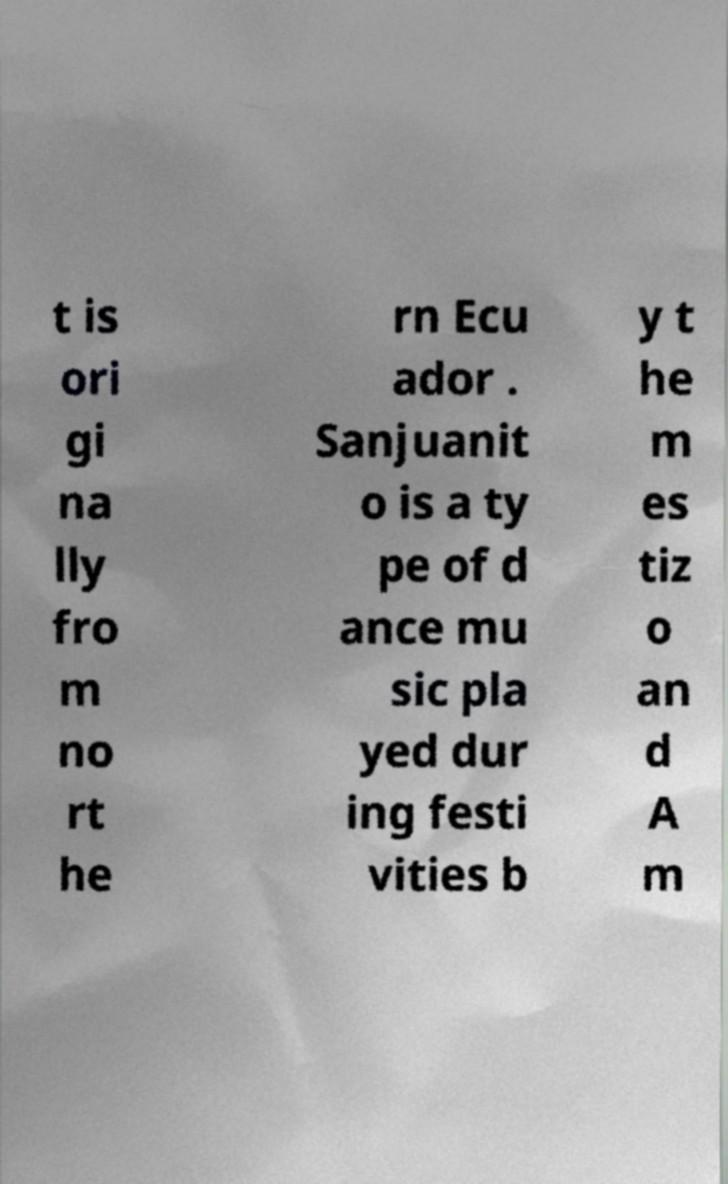Can you read and provide the text displayed in the image?This photo seems to have some interesting text. Can you extract and type it out for me? t is ori gi na lly fro m no rt he rn Ecu ador . Sanjuanit o is a ty pe of d ance mu sic pla yed dur ing festi vities b y t he m es tiz o an d A m 